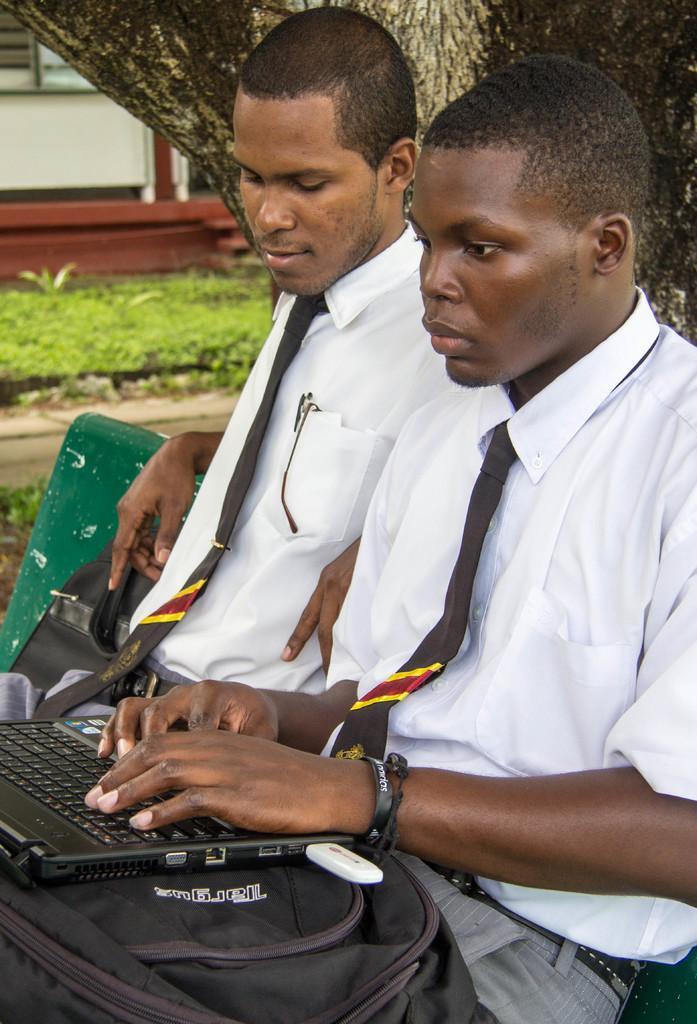Can you describe this image briefly? In this image I can see 2 people sitting, wearing white shirts and black ties. The person at the front is operating a laptop and there are bags. There is a tree trunk, grass and a building at the back. 